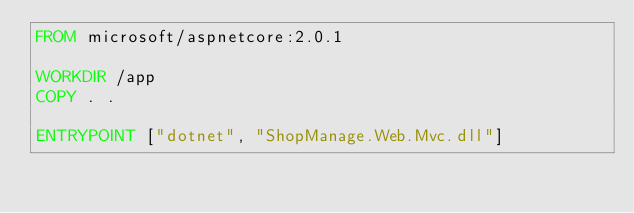<code> <loc_0><loc_0><loc_500><loc_500><_Dockerfile_>FROM microsoft/aspnetcore:2.0.1

WORKDIR /app
COPY . .

ENTRYPOINT ["dotnet", "ShopManage.Web.Mvc.dll"]
</code> 